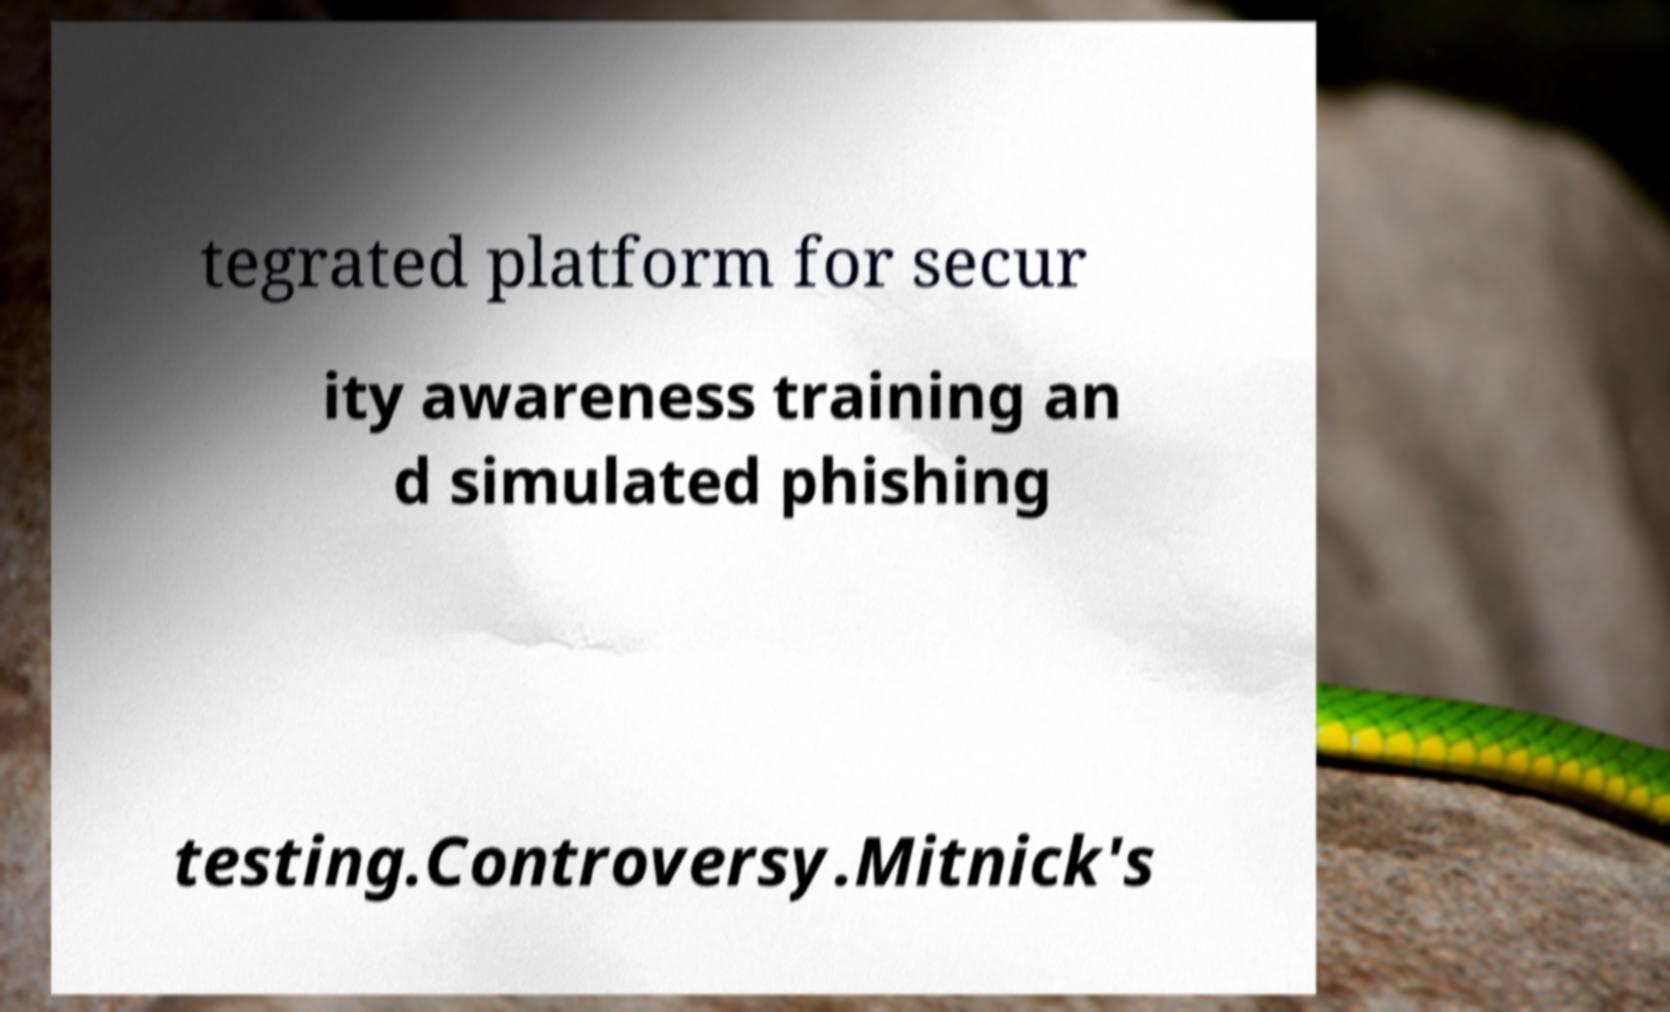Can you read and provide the text displayed in the image?This photo seems to have some interesting text. Can you extract and type it out for me? tegrated platform for secur ity awareness training an d simulated phishing testing.Controversy.Mitnick's 